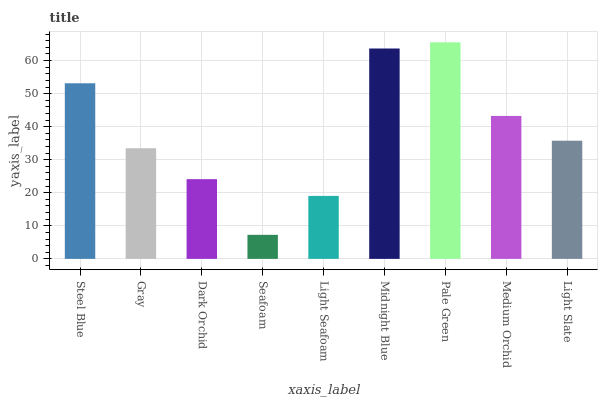Is Seafoam the minimum?
Answer yes or no. Yes. Is Pale Green the maximum?
Answer yes or no. Yes. Is Gray the minimum?
Answer yes or no. No. Is Gray the maximum?
Answer yes or no. No. Is Steel Blue greater than Gray?
Answer yes or no. Yes. Is Gray less than Steel Blue?
Answer yes or no. Yes. Is Gray greater than Steel Blue?
Answer yes or no. No. Is Steel Blue less than Gray?
Answer yes or no. No. Is Light Slate the high median?
Answer yes or no. Yes. Is Light Slate the low median?
Answer yes or no. Yes. Is Seafoam the high median?
Answer yes or no. No. Is Light Seafoam the low median?
Answer yes or no. No. 